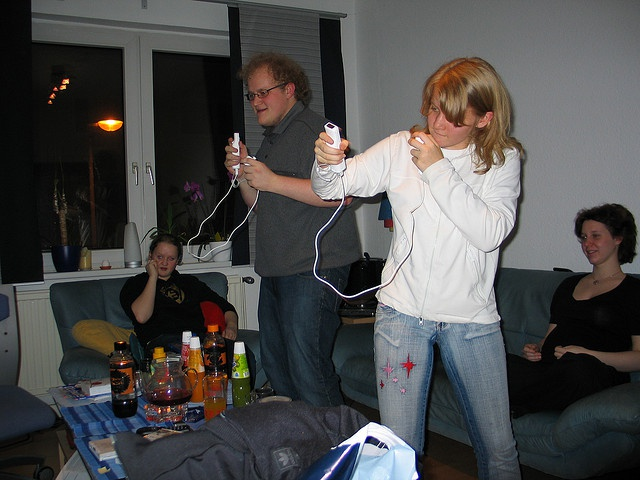Describe the objects in this image and their specific colors. I can see people in black, lightgray, gray, and darkgray tones, people in black, brown, and gray tones, couch in black, darkblue, gray, and purple tones, people in black, maroon, and brown tones, and dining table in black, navy, gray, and blue tones in this image. 